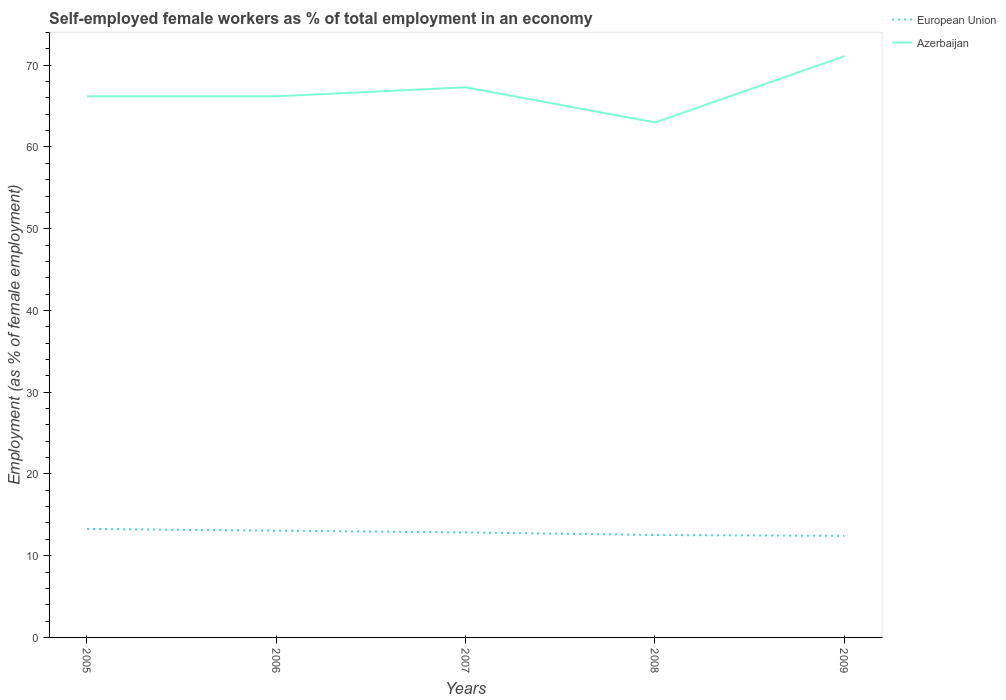Is the number of lines equal to the number of legend labels?
Give a very brief answer. Yes. Across all years, what is the maximum percentage of self-employed female workers in European Union?
Offer a terse response. 12.42. In which year was the percentage of self-employed female workers in European Union maximum?
Keep it short and to the point. 2009. What is the total percentage of self-employed female workers in Azerbaijan in the graph?
Give a very brief answer. -4.9. What is the difference between the highest and the second highest percentage of self-employed female workers in European Union?
Make the answer very short. 0.85. Is the percentage of self-employed female workers in Azerbaijan strictly greater than the percentage of self-employed female workers in European Union over the years?
Offer a terse response. No. How many lines are there?
Provide a short and direct response. 2. How many years are there in the graph?
Your answer should be compact. 5. Are the values on the major ticks of Y-axis written in scientific E-notation?
Offer a terse response. No. Does the graph contain any zero values?
Keep it short and to the point. No. Does the graph contain grids?
Give a very brief answer. No. Where does the legend appear in the graph?
Make the answer very short. Top right. How many legend labels are there?
Provide a succinct answer. 2. What is the title of the graph?
Your answer should be compact. Self-employed female workers as % of total employment in an economy. What is the label or title of the Y-axis?
Your answer should be compact. Employment (as % of female employment). What is the Employment (as % of female employment) in European Union in 2005?
Your response must be concise. 13.27. What is the Employment (as % of female employment) in Azerbaijan in 2005?
Make the answer very short. 66.2. What is the Employment (as % of female employment) in European Union in 2006?
Your response must be concise. 13.06. What is the Employment (as % of female employment) of Azerbaijan in 2006?
Keep it short and to the point. 66.2. What is the Employment (as % of female employment) in European Union in 2007?
Your answer should be very brief. 12.84. What is the Employment (as % of female employment) in Azerbaijan in 2007?
Make the answer very short. 67.3. What is the Employment (as % of female employment) in European Union in 2008?
Make the answer very short. 12.53. What is the Employment (as % of female employment) in European Union in 2009?
Ensure brevity in your answer.  12.42. What is the Employment (as % of female employment) in Azerbaijan in 2009?
Your answer should be compact. 71.1. Across all years, what is the maximum Employment (as % of female employment) in European Union?
Give a very brief answer. 13.27. Across all years, what is the maximum Employment (as % of female employment) of Azerbaijan?
Your response must be concise. 71.1. Across all years, what is the minimum Employment (as % of female employment) in European Union?
Keep it short and to the point. 12.42. Across all years, what is the minimum Employment (as % of female employment) in Azerbaijan?
Your answer should be compact. 63. What is the total Employment (as % of female employment) of European Union in the graph?
Provide a short and direct response. 64.13. What is the total Employment (as % of female employment) in Azerbaijan in the graph?
Give a very brief answer. 333.8. What is the difference between the Employment (as % of female employment) in European Union in 2005 and that in 2006?
Give a very brief answer. 0.21. What is the difference between the Employment (as % of female employment) in Azerbaijan in 2005 and that in 2006?
Give a very brief answer. 0. What is the difference between the Employment (as % of female employment) of European Union in 2005 and that in 2007?
Offer a very short reply. 0.43. What is the difference between the Employment (as % of female employment) of Azerbaijan in 2005 and that in 2007?
Offer a very short reply. -1.1. What is the difference between the Employment (as % of female employment) of European Union in 2005 and that in 2008?
Provide a short and direct response. 0.74. What is the difference between the Employment (as % of female employment) of Azerbaijan in 2005 and that in 2008?
Ensure brevity in your answer.  3.2. What is the difference between the Employment (as % of female employment) in European Union in 2005 and that in 2009?
Provide a short and direct response. 0.85. What is the difference between the Employment (as % of female employment) in European Union in 2006 and that in 2007?
Provide a succinct answer. 0.22. What is the difference between the Employment (as % of female employment) in Azerbaijan in 2006 and that in 2007?
Offer a terse response. -1.1. What is the difference between the Employment (as % of female employment) in European Union in 2006 and that in 2008?
Provide a succinct answer. 0.53. What is the difference between the Employment (as % of female employment) of Azerbaijan in 2006 and that in 2008?
Provide a succinct answer. 3.2. What is the difference between the Employment (as % of female employment) in European Union in 2006 and that in 2009?
Your response must be concise. 0.64. What is the difference between the Employment (as % of female employment) of European Union in 2007 and that in 2008?
Provide a succinct answer. 0.31. What is the difference between the Employment (as % of female employment) of Azerbaijan in 2007 and that in 2008?
Provide a succinct answer. 4.3. What is the difference between the Employment (as % of female employment) in European Union in 2007 and that in 2009?
Offer a terse response. 0.42. What is the difference between the Employment (as % of female employment) of Azerbaijan in 2007 and that in 2009?
Keep it short and to the point. -3.8. What is the difference between the Employment (as % of female employment) of European Union in 2008 and that in 2009?
Ensure brevity in your answer.  0.11. What is the difference between the Employment (as % of female employment) in European Union in 2005 and the Employment (as % of female employment) in Azerbaijan in 2006?
Provide a short and direct response. -52.93. What is the difference between the Employment (as % of female employment) of European Union in 2005 and the Employment (as % of female employment) of Azerbaijan in 2007?
Your answer should be very brief. -54.03. What is the difference between the Employment (as % of female employment) of European Union in 2005 and the Employment (as % of female employment) of Azerbaijan in 2008?
Your answer should be very brief. -49.73. What is the difference between the Employment (as % of female employment) in European Union in 2005 and the Employment (as % of female employment) in Azerbaijan in 2009?
Provide a succinct answer. -57.83. What is the difference between the Employment (as % of female employment) in European Union in 2006 and the Employment (as % of female employment) in Azerbaijan in 2007?
Provide a succinct answer. -54.24. What is the difference between the Employment (as % of female employment) in European Union in 2006 and the Employment (as % of female employment) in Azerbaijan in 2008?
Keep it short and to the point. -49.94. What is the difference between the Employment (as % of female employment) in European Union in 2006 and the Employment (as % of female employment) in Azerbaijan in 2009?
Your answer should be very brief. -58.04. What is the difference between the Employment (as % of female employment) of European Union in 2007 and the Employment (as % of female employment) of Azerbaijan in 2008?
Keep it short and to the point. -50.16. What is the difference between the Employment (as % of female employment) in European Union in 2007 and the Employment (as % of female employment) in Azerbaijan in 2009?
Ensure brevity in your answer.  -58.26. What is the difference between the Employment (as % of female employment) of European Union in 2008 and the Employment (as % of female employment) of Azerbaijan in 2009?
Your answer should be compact. -58.57. What is the average Employment (as % of female employment) of European Union per year?
Offer a terse response. 12.83. What is the average Employment (as % of female employment) in Azerbaijan per year?
Offer a very short reply. 66.76. In the year 2005, what is the difference between the Employment (as % of female employment) of European Union and Employment (as % of female employment) of Azerbaijan?
Make the answer very short. -52.93. In the year 2006, what is the difference between the Employment (as % of female employment) of European Union and Employment (as % of female employment) of Azerbaijan?
Provide a short and direct response. -53.14. In the year 2007, what is the difference between the Employment (as % of female employment) in European Union and Employment (as % of female employment) in Azerbaijan?
Your answer should be very brief. -54.46. In the year 2008, what is the difference between the Employment (as % of female employment) in European Union and Employment (as % of female employment) in Azerbaijan?
Your answer should be compact. -50.47. In the year 2009, what is the difference between the Employment (as % of female employment) of European Union and Employment (as % of female employment) of Azerbaijan?
Offer a terse response. -58.68. What is the ratio of the Employment (as % of female employment) of European Union in 2005 to that in 2006?
Give a very brief answer. 1.02. What is the ratio of the Employment (as % of female employment) of Azerbaijan in 2005 to that in 2006?
Keep it short and to the point. 1. What is the ratio of the Employment (as % of female employment) in European Union in 2005 to that in 2007?
Offer a very short reply. 1.03. What is the ratio of the Employment (as % of female employment) of Azerbaijan in 2005 to that in 2007?
Your response must be concise. 0.98. What is the ratio of the Employment (as % of female employment) of European Union in 2005 to that in 2008?
Provide a short and direct response. 1.06. What is the ratio of the Employment (as % of female employment) of Azerbaijan in 2005 to that in 2008?
Provide a succinct answer. 1.05. What is the ratio of the Employment (as % of female employment) in European Union in 2005 to that in 2009?
Offer a very short reply. 1.07. What is the ratio of the Employment (as % of female employment) in Azerbaijan in 2005 to that in 2009?
Offer a terse response. 0.93. What is the ratio of the Employment (as % of female employment) of European Union in 2006 to that in 2007?
Offer a very short reply. 1.02. What is the ratio of the Employment (as % of female employment) in Azerbaijan in 2006 to that in 2007?
Offer a very short reply. 0.98. What is the ratio of the Employment (as % of female employment) in European Union in 2006 to that in 2008?
Keep it short and to the point. 1.04. What is the ratio of the Employment (as % of female employment) of Azerbaijan in 2006 to that in 2008?
Give a very brief answer. 1.05. What is the ratio of the Employment (as % of female employment) in European Union in 2006 to that in 2009?
Offer a terse response. 1.05. What is the ratio of the Employment (as % of female employment) in Azerbaijan in 2006 to that in 2009?
Your answer should be compact. 0.93. What is the ratio of the Employment (as % of female employment) in European Union in 2007 to that in 2008?
Provide a succinct answer. 1.02. What is the ratio of the Employment (as % of female employment) in Azerbaijan in 2007 to that in 2008?
Offer a terse response. 1.07. What is the ratio of the Employment (as % of female employment) in European Union in 2007 to that in 2009?
Provide a short and direct response. 1.03. What is the ratio of the Employment (as % of female employment) in Azerbaijan in 2007 to that in 2009?
Make the answer very short. 0.95. What is the ratio of the Employment (as % of female employment) of European Union in 2008 to that in 2009?
Make the answer very short. 1.01. What is the ratio of the Employment (as % of female employment) of Azerbaijan in 2008 to that in 2009?
Make the answer very short. 0.89. What is the difference between the highest and the second highest Employment (as % of female employment) in European Union?
Provide a succinct answer. 0.21. What is the difference between the highest and the lowest Employment (as % of female employment) of European Union?
Provide a short and direct response. 0.85. What is the difference between the highest and the lowest Employment (as % of female employment) in Azerbaijan?
Provide a short and direct response. 8.1. 